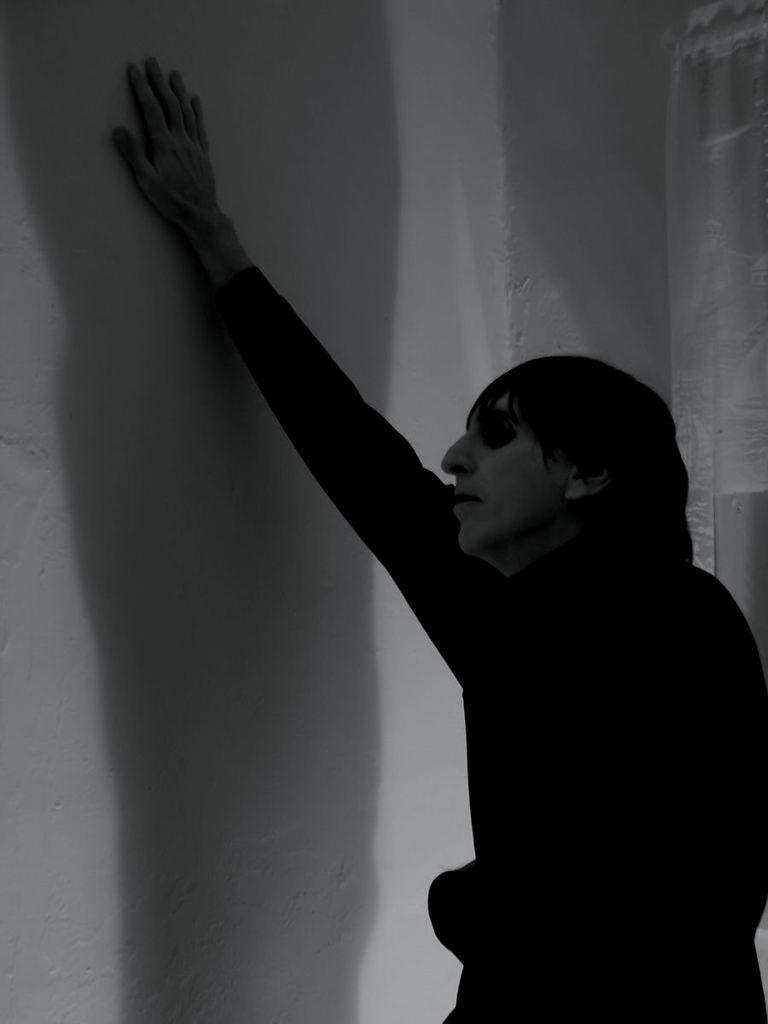What is the main subject of the image? There is a man in the image. What is the man doing in the image? The man is standing in the image. Can you describe the man's position or posture in the image? The man's hand is on the wall in the image. What type of stone can be seen in the man's hand in the image? There is no stone visible in the man's hand in the image. Is there a stream flowing near the man in the image? There is no stream present in the image. 